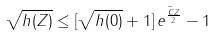Convert formula to latex. <formula><loc_0><loc_0><loc_500><loc_500>\sqrt { h ( Z ) } \leq [ \sqrt { h ( 0 ) } + 1 ] \, e ^ { \frac { \widetilde { C } Z } { 2 } } - 1</formula> 